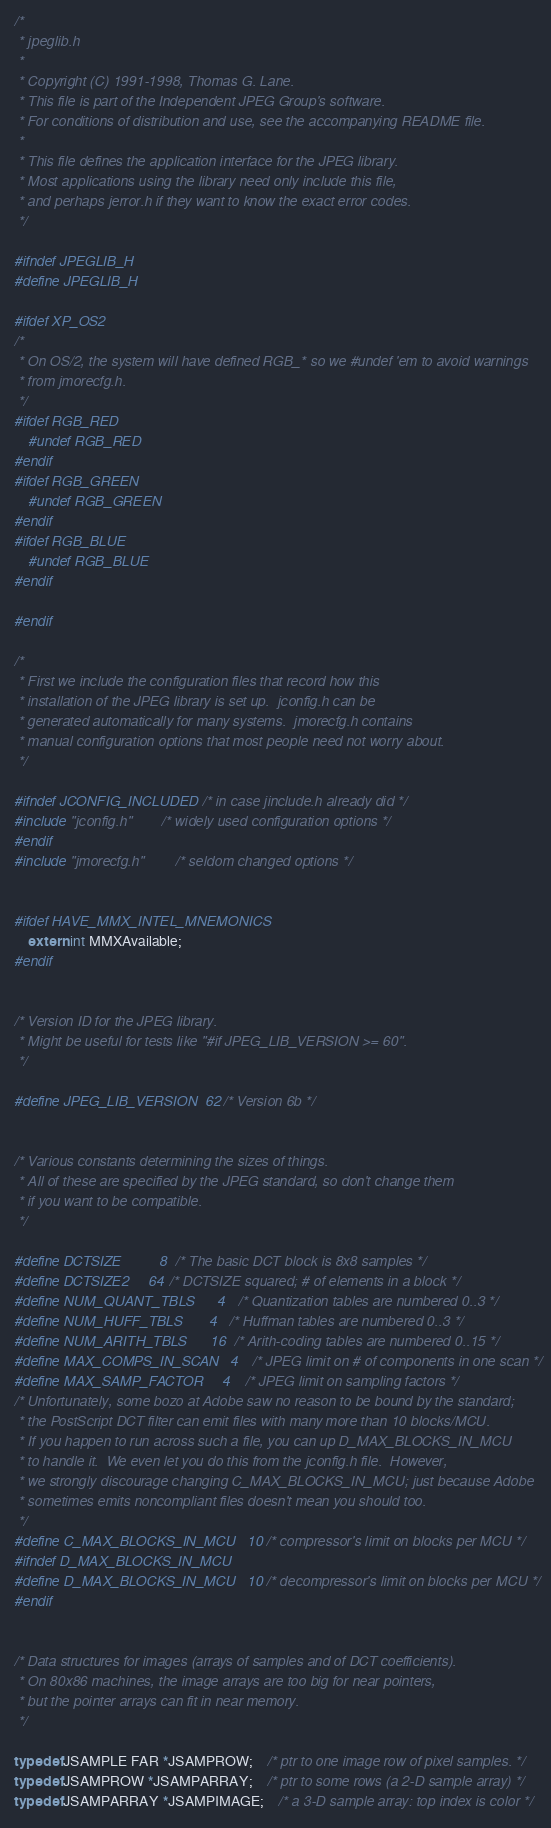Convert code to text. <code><loc_0><loc_0><loc_500><loc_500><_C_>/*
 * jpeglib.h
 *
 * Copyright (C) 1991-1998, Thomas G. Lane.
 * This file is part of the Independent JPEG Group's software.
 * For conditions of distribution and use, see the accompanying README file.
 *
 * This file defines the application interface for the JPEG library.
 * Most applications using the library need only include this file,
 * and perhaps jerror.h if they want to know the exact error codes.
 */

#ifndef JPEGLIB_H
#define JPEGLIB_H

#ifdef XP_OS2
/*
 * On OS/2, the system will have defined RGB_* so we #undef 'em to avoid warnings
 * from jmorecfg.h.
 */
#ifdef RGB_RED
	#undef RGB_RED
#endif
#ifdef RGB_GREEN
	#undef RGB_GREEN
#endif
#ifdef RGB_BLUE
	#undef RGB_BLUE
#endif

#endif

/*
 * First we include the configuration files that record how this
 * installation of the JPEG library is set up.  jconfig.h can be
 * generated automatically for many systems.  jmorecfg.h contains
 * manual configuration options that most people need not worry about.
 */

#ifndef JCONFIG_INCLUDED	/* in case jinclude.h already did */
#include "jconfig.h"		/* widely used configuration options */
#endif
#include "jmorecfg.h"		/* seldom changed options */


#ifdef HAVE_MMX_INTEL_MNEMONICS
	extern int MMXAvailable;
#endif


/* Version ID for the JPEG library.
 * Might be useful for tests like "#if JPEG_LIB_VERSION >= 60".
 */

#define JPEG_LIB_VERSION  62	/* Version 6b */


/* Various constants determining the sizes of things.
 * All of these are specified by the JPEG standard, so don't change them
 * if you want to be compatible.
 */

#define DCTSIZE		    8	/* The basic DCT block is 8x8 samples */
#define DCTSIZE2	    64	/* DCTSIZE squared; # of elements in a block */
#define NUM_QUANT_TBLS      4	/* Quantization tables are numbered 0..3 */
#define NUM_HUFF_TBLS       4	/* Huffman tables are numbered 0..3 */
#define NUM_ARITH_TBLS      16	/* Arith-coding tables are numbered 0..15 */
#define MAX_COMPS_IN_SCAN   4	/* JPEG limit on # of components in one scan */
#define MAX_SAMP_FACTOR     4	/* JPEG limit on sampling factors */
/* Unfortunately, some bozo at Adobe saw no reason to be bound by the standard;
 * the PostScript DCT filter can emit files with many more than 10 blocks/MCU.
 * If you happen to run across such a file, you can up D_MAX_BLOCKS_IN_MCU
 * to handle it.  We even let you do this from the jconfig.h file.  However,
 * we strongly discourage changing C_MAX_BLOCKS_IN_MCU; just because Adobe
 * sometimes emits noncompliant files doesn't mean you should too.
 */
#define C_MAX_BLOCKS_IN_MCU   10 /* compressor's limit on blocks per MCU */
#ifndef D_MAX_BLOCKS_IN_MCU
#define D_MAX_BLOCKS_IN_MCU   10 /* decompressor's limit on blocks per MCU */
#endif


/* Data structures for images (arrays of samples and of DCT coefficients).
 * On 80x86 machines, the image arrays are too big for near pointers,
 * but the pointer arrays can fit in near memory.
 */

typedef JSAMPLE FAR *JSAMPROW;	/* ptr to one image row of pixel samples. */
typedef JSAMPROW *JSAMPARRAY;	/* ptr to some rows (a 2-D sample array) */
typedef JSAMPARRAY *JSAMPIMAGE;	/* a 3-D sample array: top index is color */
</code> 